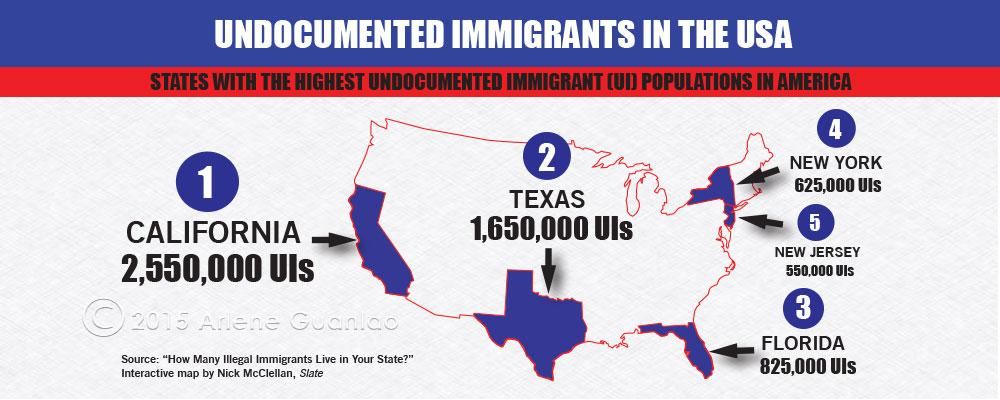Point out several critical features in this image. There are approximately 1,650,000 undocumented immigrants living in Texas as of 2021. 